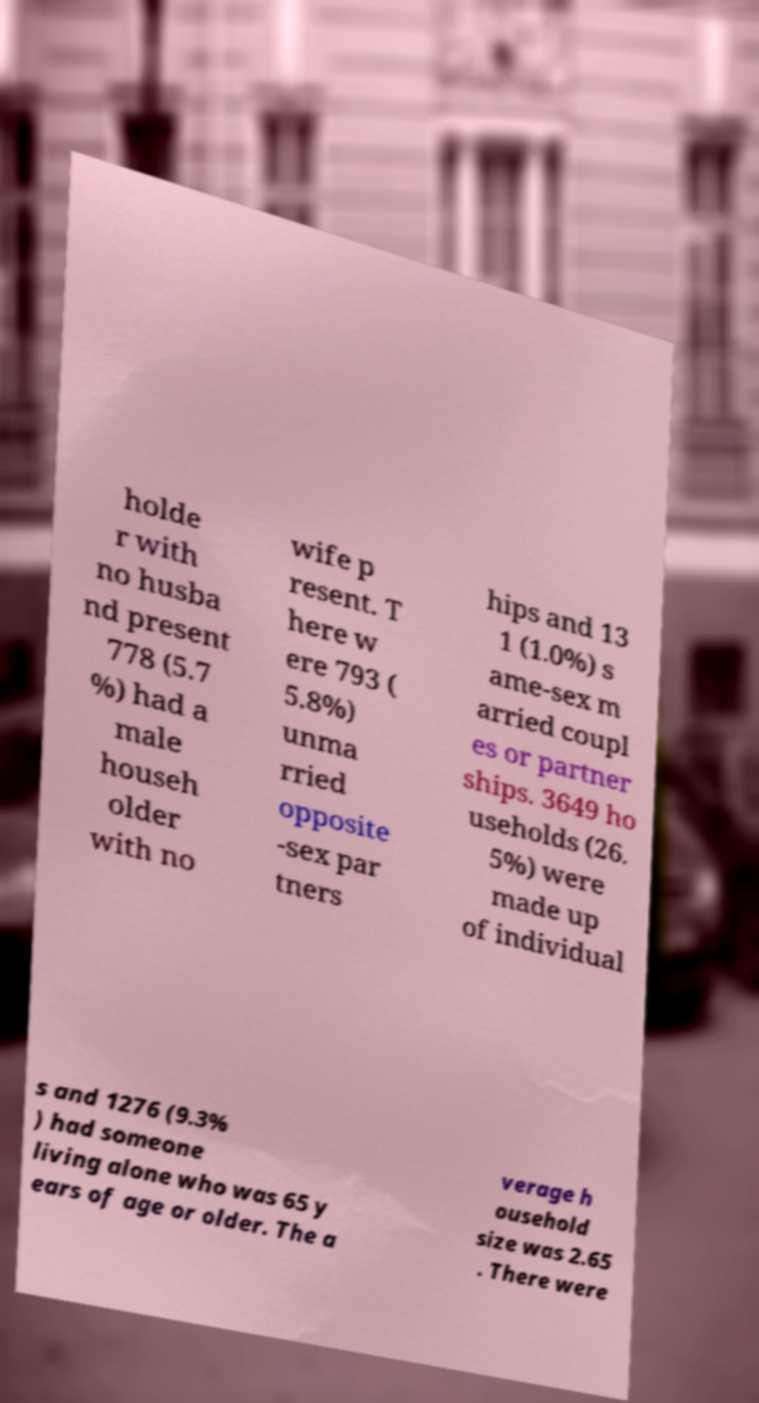There's text embedded in this image that I need extracted. Can you transcribe it verbatim? holde r with no husba nd present 778 (5.7 %) had a male househ older with no wife p resent. T here w ere 793 ( 5.8%) unma rried opposite -sex par tners hips and 13 1 (1.0%) s ame-sex m arried coupl es or partner ships. 3649 ho useholds (26. 5%) were made up of individual s and 1276 (9.3% ) had someone living alone who was 65 y ears of age or older. The a verage h ousehold size was 2.65 . There were 